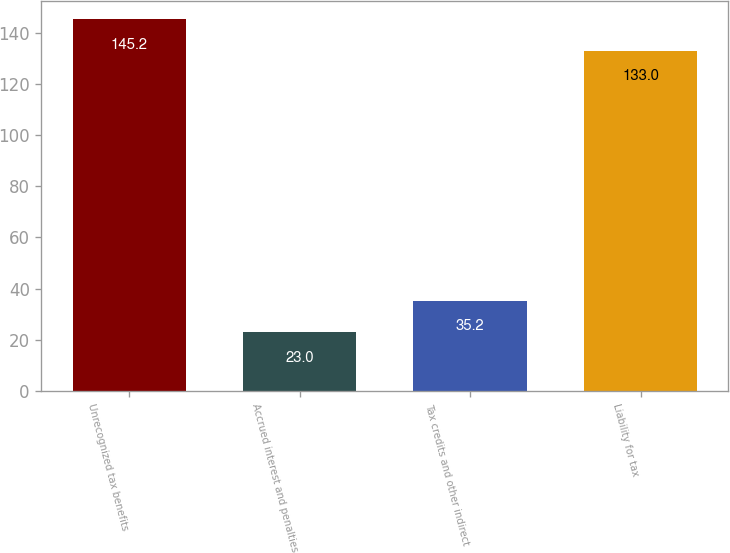Convert chart. <chart><loc_0><loc_0><loc_500><loc_500><bar_chart><fcel>Unrecognized tax benefits<fcel>Accrued interest and penalties<fcel>Tax credits and other indirect<fcel>Liability for tax<nl><fcel>145.2<fcel>23<fcel>35.2<fcel>133<nl></chart> 